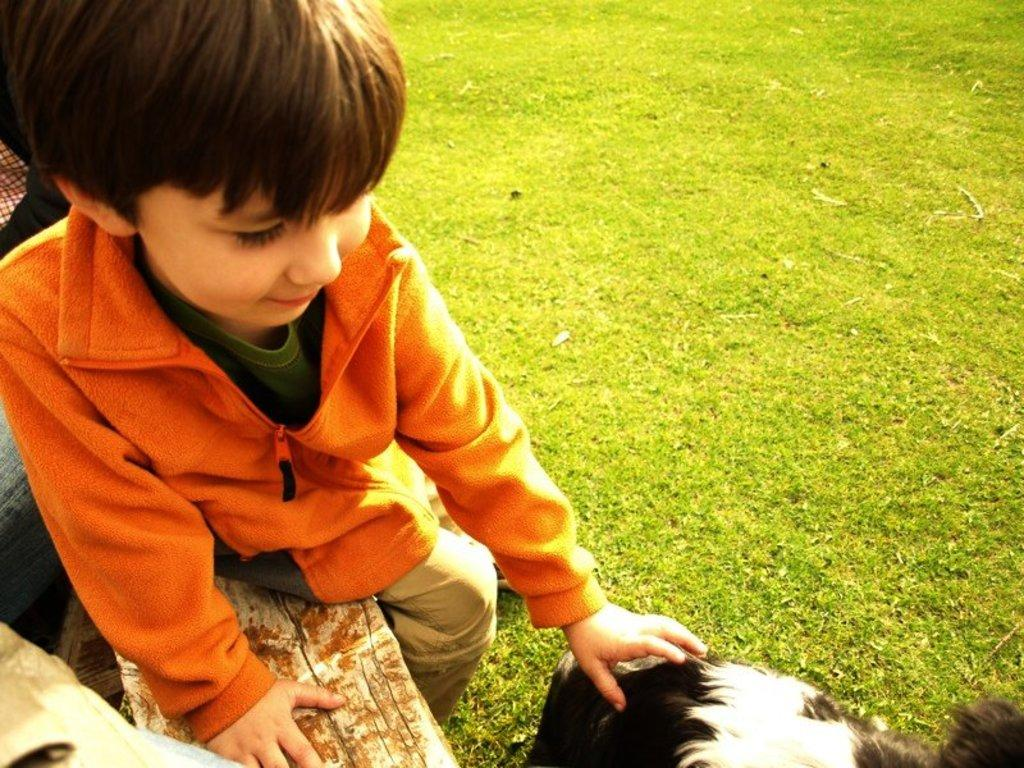What color is the jacket the kid is wearing in the image? The kid is wearing an orange jacket in the image. What is the color of the grass in the image? The grass is green in color. Can you describe the animal beside the kid? There is an animal beside the kid in the image. What is the kid's brother doing in the image? There is no mention of a brother in the image, so we cannot determine what the brother might be doing. 